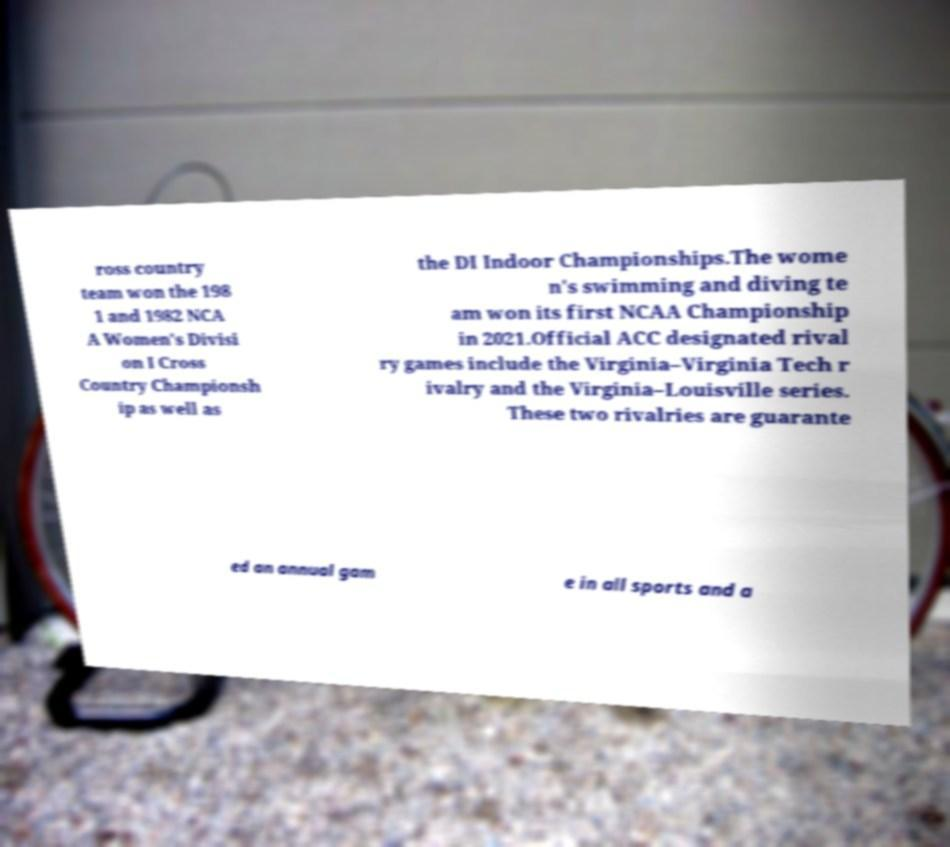For documentation purposes, I need the text within this image transcribed. Could you provide that? ross country team won the 198 1 and 1982 NCA A Women's Divisi on I Cross Country Championsh ip as well as the DI Indoor Championships.The wome n's swimming and diving te am won its first NCAA Championship in 2021.Official ACC designated rival ry games include the Virginia–Virginia Tech r ivalry and the Virginia–Louisville series. These two rivalries are guarante ed an annual gam e in all sports and a 